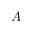<formula> <loc_0><loc_0><loc_500><loc_500>A</formula> 